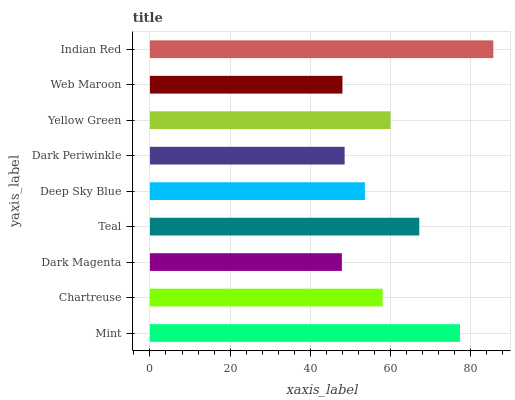Is Dark Magenta the minimum?
Answer yes or no. Yes. Is Indian Red the maximum?
Answer yes or no. Yes. Is Chartreuse the minimum?
Answer yes or no. No. Is Chartreuse the maximum?
Answer yes or no. No. Is Mint greater than Chartreuse?
Answer yes or no. Yes. Is Chartreuse less than Mint?
Answer yes or no. Yes. Is Chartreuse greater than Mint?
Answer yes or no. No. Is Mint less than Chartreuse?
Answer yes or no. No. Is Chartreuse the high median?
Answer yes or no. Yes. Is Chartreuse the low median?
Answer yes or no. Yes. Is Web Maroon the high median?
Answer yes or no. No. Is Dark Magenta the low median?
Answer yes or no. No. 